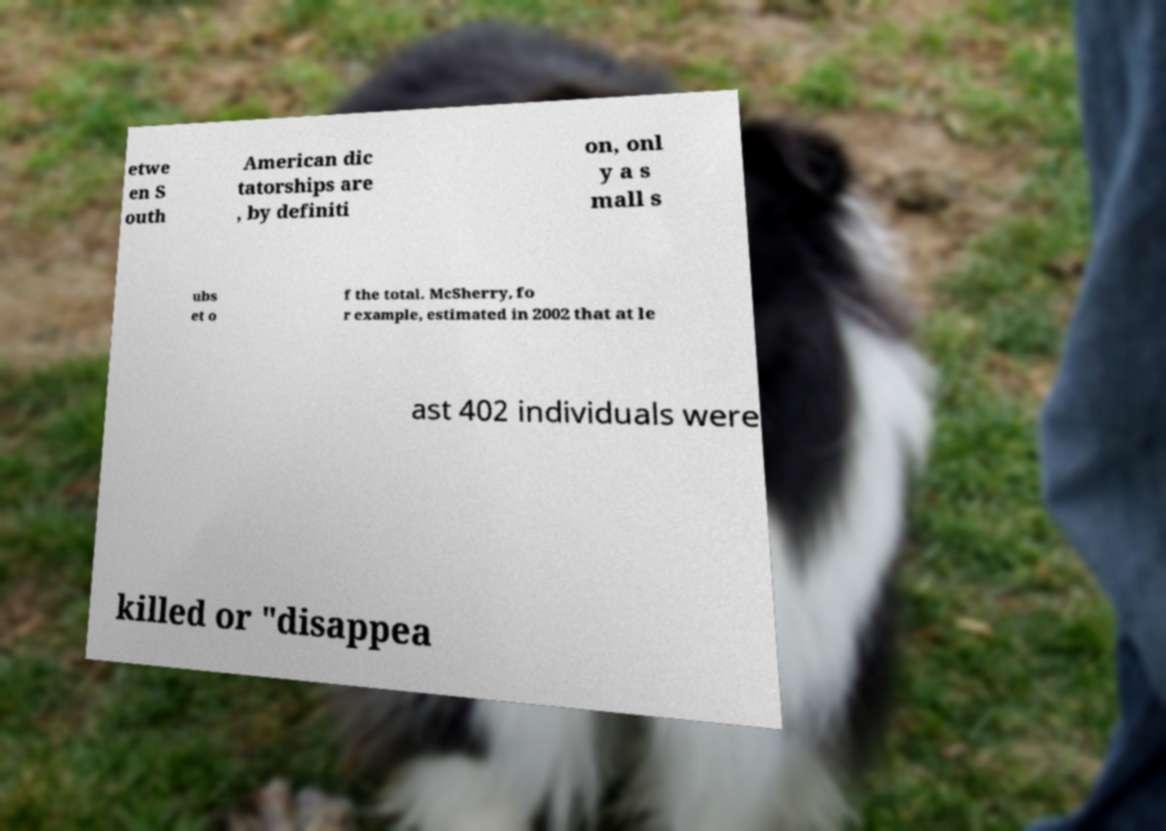For documentation purposes, I need the text within this image transcribed. Could you provide that? etwe en S outh American dic tatorships are , by definiti on, onl y a s mall s ubs et o f the total. McSherry, fo r example, estimated in 2002 that at le ast 402 individuals were killed or "disappea 